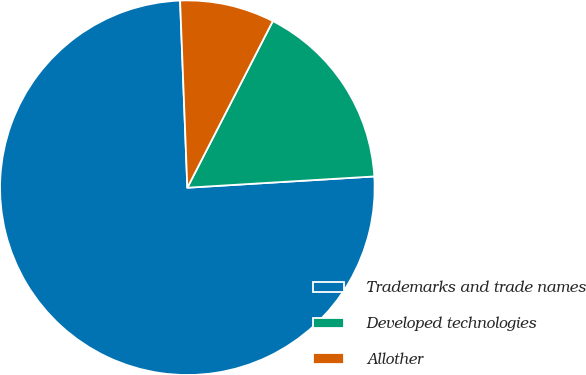Convert chart. <chart><loc_0><loc_0><loc_500><loc_500><pie_chart><fcel>Trademarks and trade names<fcel>Developed technologies<fcel>Allother<nl><fcel>75.34%<fcel>16.5%<fcel>8.16%<nl></chart> 